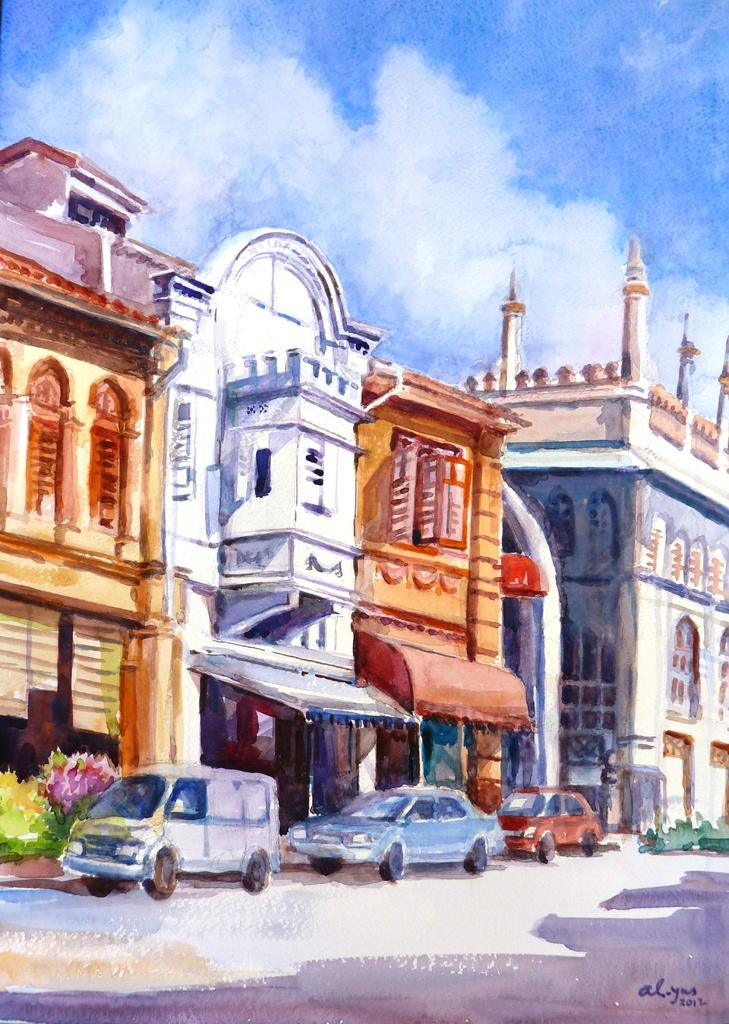What type of artwork is depicted in the image? The image is a painting. What structures are present in the painting? There are buildings in the painting. What type of vehicles can be seen in the painting? There are cars in the painting. What type of vegetation is present in the painting? There are bushes in the painting. What is visible in the background of the painting? The sky is visible in the background of the painting. What type of offer is being made by the train in the painting? There is no train present in the painting, so no offer can be made by a train. 